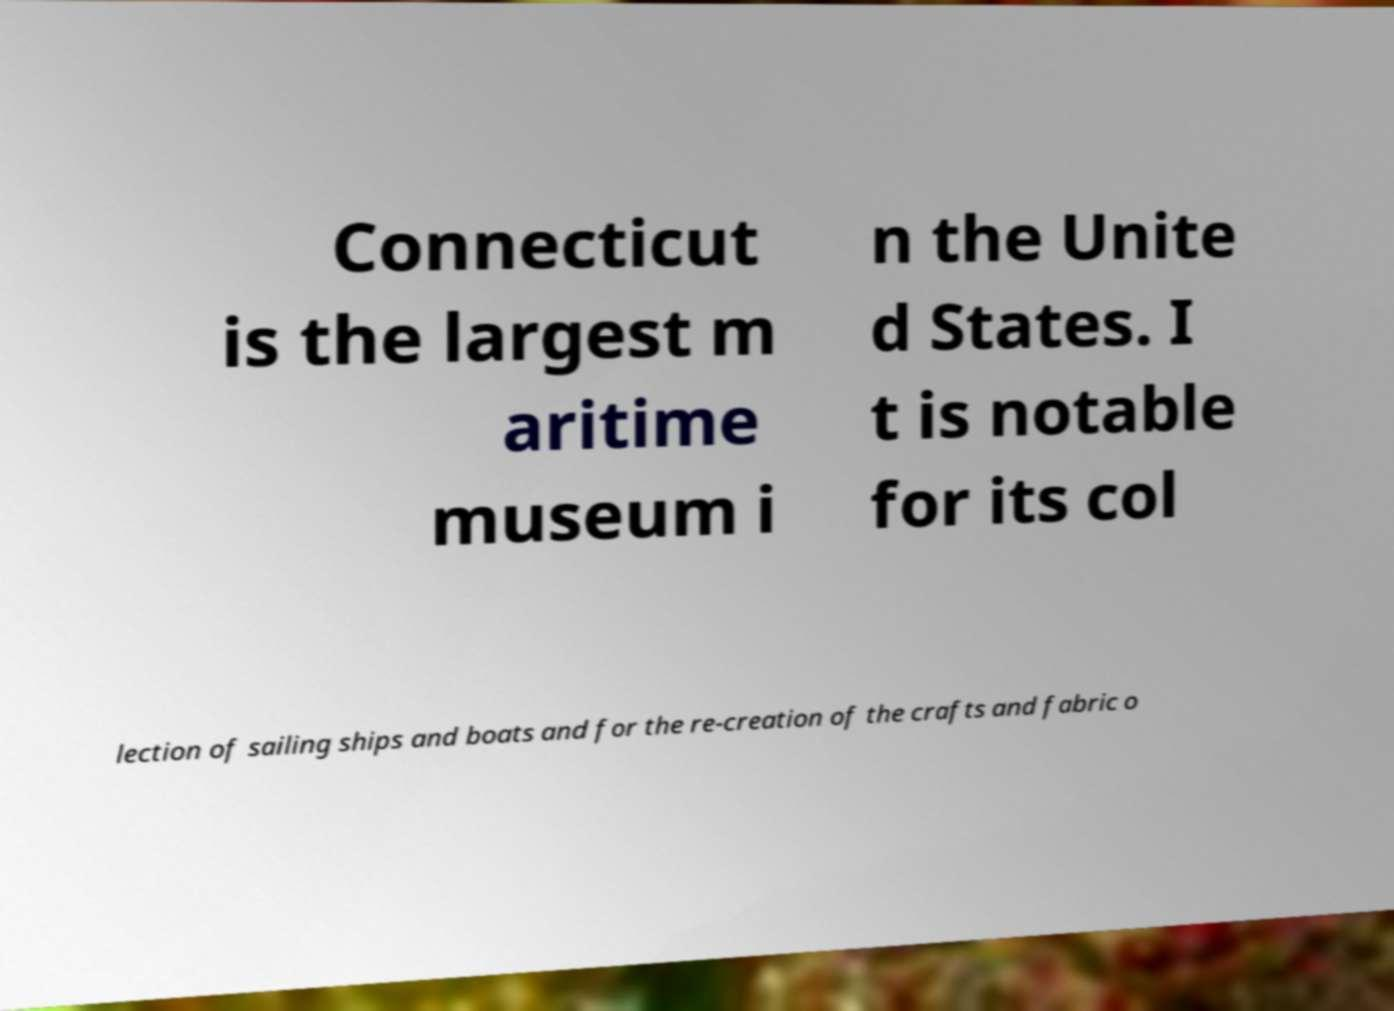For documentation purposes, I need the text within this image transcribed. Could you provide that? Connecticut is the largest m aritime museum i n the Unite d States. I t is notable for its col lection of sailing ships and boats and for the re-creation of the crafts and fabric o 